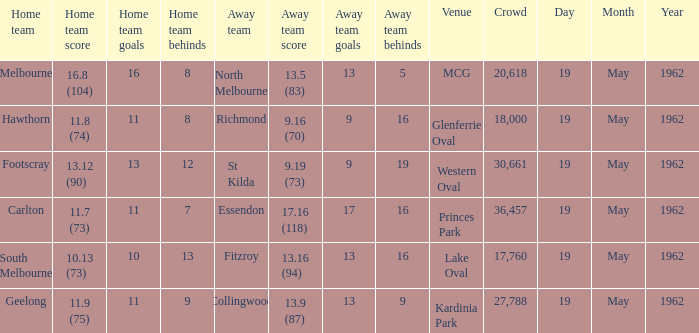What is the away team's score when the home team scores 16.8 (104)? 13.5 (83). 